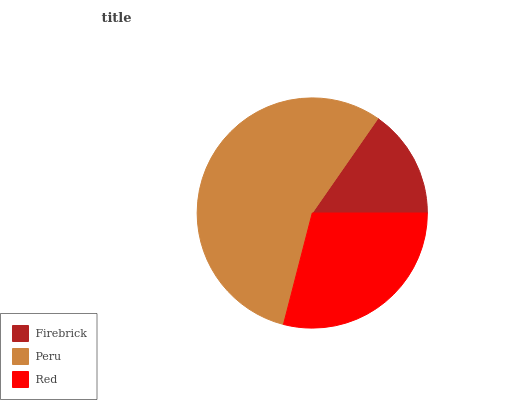Is Firebrick the minimum?
Answer yes or no. Yes. Is Peru the maximum?
Answer yes or no. Yes. Is Red the minimum?
Answer yes or no. No. Is Red the maximum?
Answer yes or no. No. Is Peru greater than Red?
Answer yes or no. Yes. Is Red less than Peru?
Answer yes or no. Yes. Is Red greater than Peru?
Answer yes or no. No. Is Peru less than Red?
Answer yes or no. No. Is Red the high median?
Answer yes or no. Yes. Is Red the low median?
Answer yes or no. Yes. Is Firebrick the high median?
Answer yes or no. No. Is Firebrick the low median?
Answer yes or no. No. 